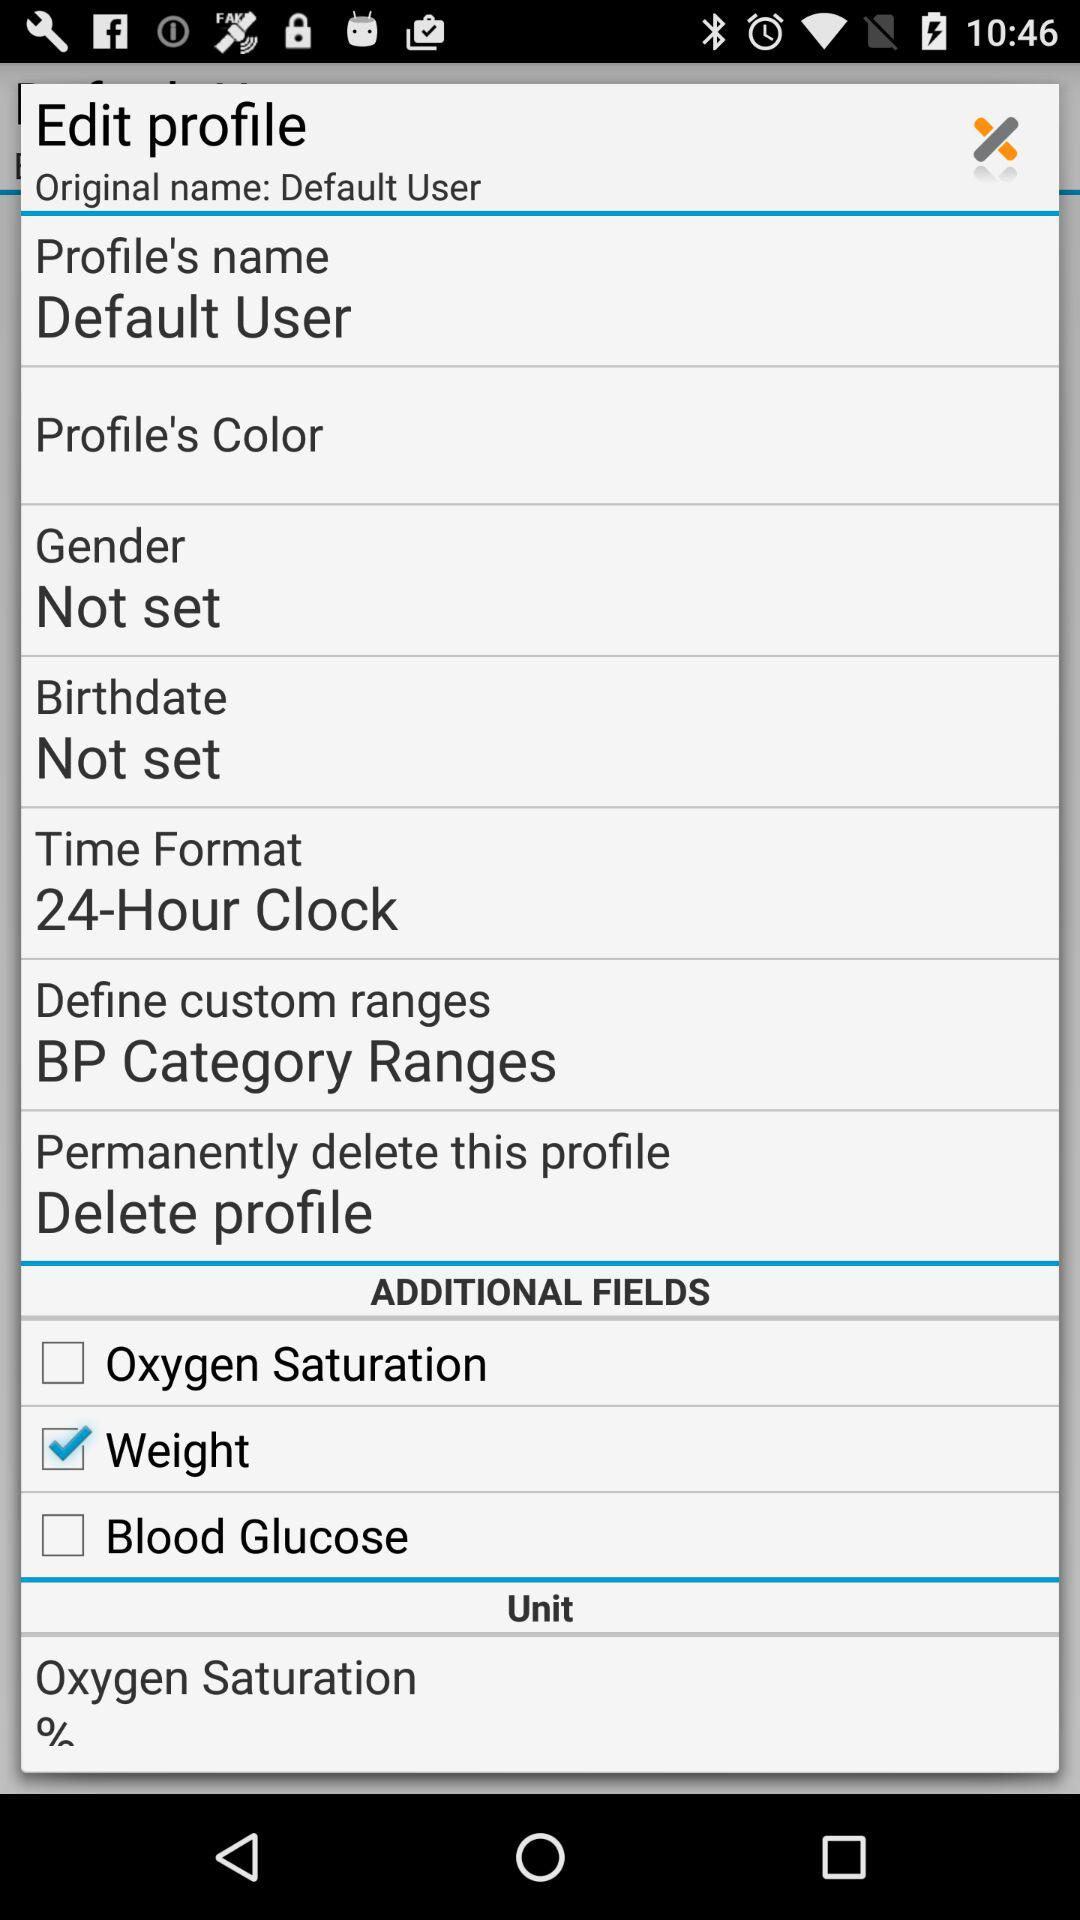What time format is selected? The selected time format is "24-Hour Clock". 